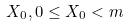<formula> <loc_0><loc_0><loc_500><loc_500>X _ { 0 } , 0 \leq X _ { 0 } < m</formula> 